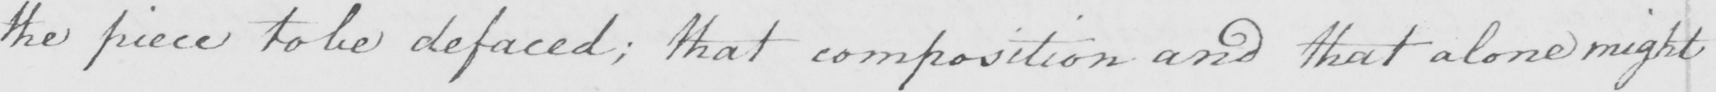What does this handwritten line say? the piece to be defaced ; that composition and that alone might 